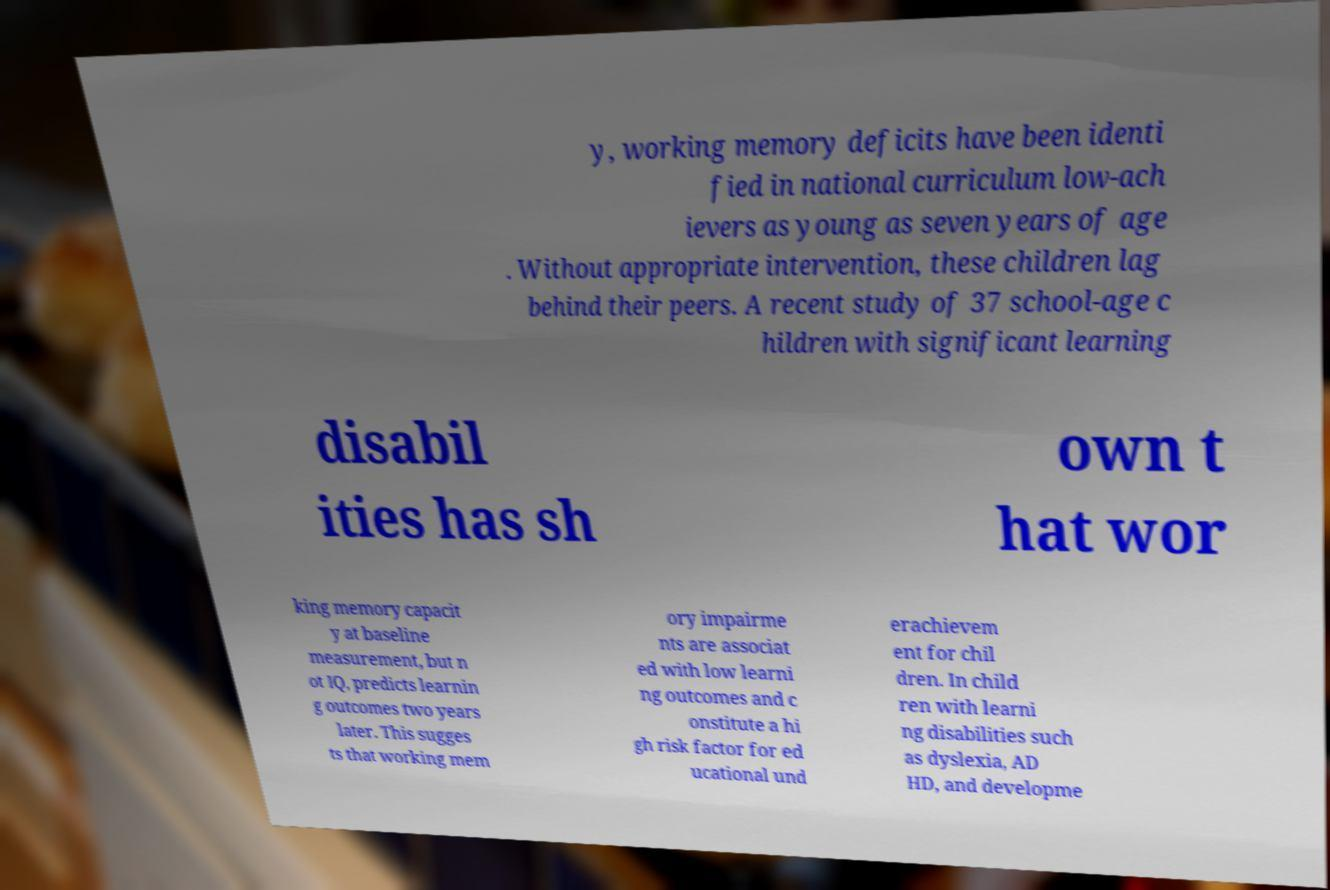Could you assist in decoding the text presented in this image and type it out clearly? y, working memory deficits have been identi fied in national curriculum low-ach ievers as young as seven years of age . Without appropriate intervention, these children lag behind their peers. A recent study of 37 school-age c hildren with significant learning disabil ities has sh own t hat wor king memory capacit y at baseline measurement, but n ot IQ, predicts learnin g outcomes two years later. This sugges ts that working mem ory impairme nts are associat ed with low learni ng outcomes and c onstitute a hi gh risk factor for ed ucational und erachievem ent for chil dren. In child ren with learni ng disabilities such as dyslexia, AD HD, and developme 